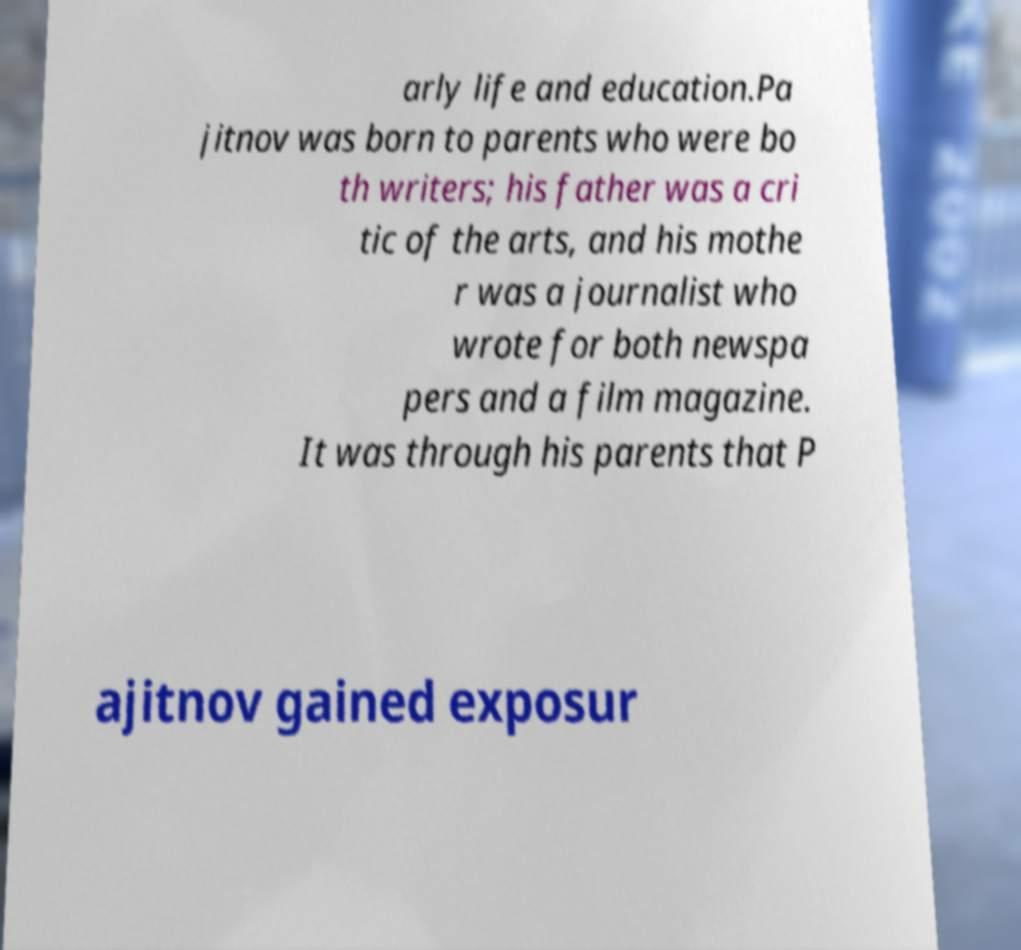I need the written content from this picture converted into text. Can you do that? arly life and education.Pa jitnov was born to parents who were bo th writers; his father was a cri tic of the arts, and his mothe r was a journalist who wrote for both newspa pers and a film magazine. It was through his parents that P ajitnov gained exposur 